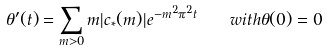Convert formula to latex. <formula><loc_0><loc_0><loc_500><loc_500>\theta ^ { \prime } ( t ) = \sum _ { m > 0 } m | c _ { * } ( m ) | e ^ { - m ^ { 2 } \pi ^ { 2 } t } \quad w i t h \theta ( 0 ) = 0</formula> 